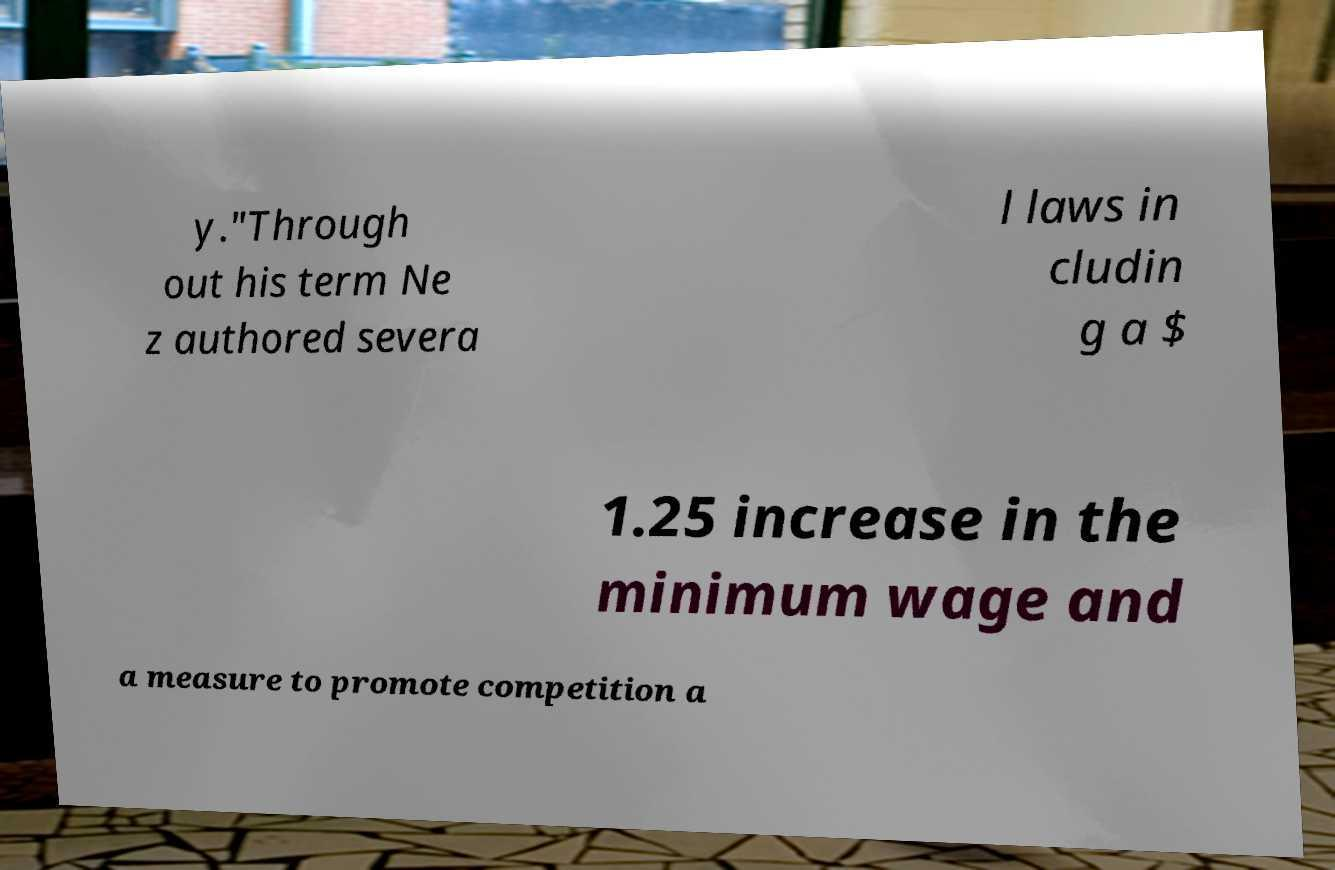Can you accurately transcribe the text from the provided image for me? y."Through out his term Ne z authored severa l laws in cludin g a $ 1.25 increase in the minimum wage and a measure to promote competition a 